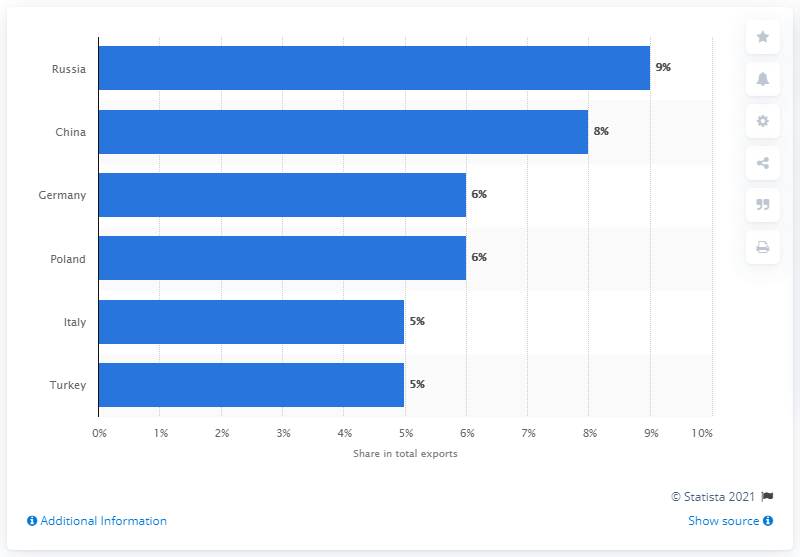Give some essential details in this illustration. In 2019, Ukraine's main export partner was Russia, accounting for the majority of its total exports. 